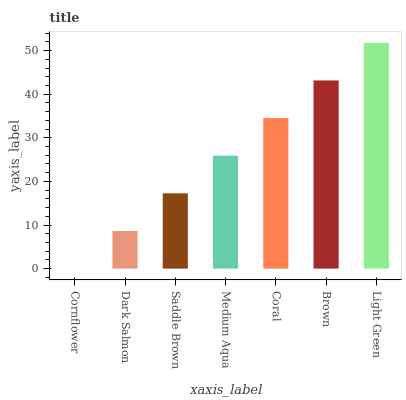Is Dark Salmon the minimum?
Answer yes or no. No. Is Dark Salmon the maximum?
Answer yes or no. No. Is Dark Salmon greater than Cornflower?
Answer yes or no. Yes. Is Cornflower less than Dark Salmon?
Answer yes or no. Yes. Is Cornflower greater than Dark Salmon?
Answer yes or no. No. Is Dark Salmon less than Cornflower?
Answer yes or no. No. Is Medium Aqua the high median?
Answer yes or no. Yes. Is Medium Aqua the low median?
Answer yes or no. Yes. Is Cornflower the high median?
Answer yes or no. No. Is Light Green the low median?
Answer yes or no. No. 